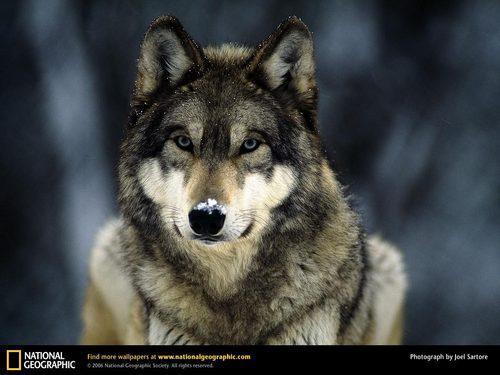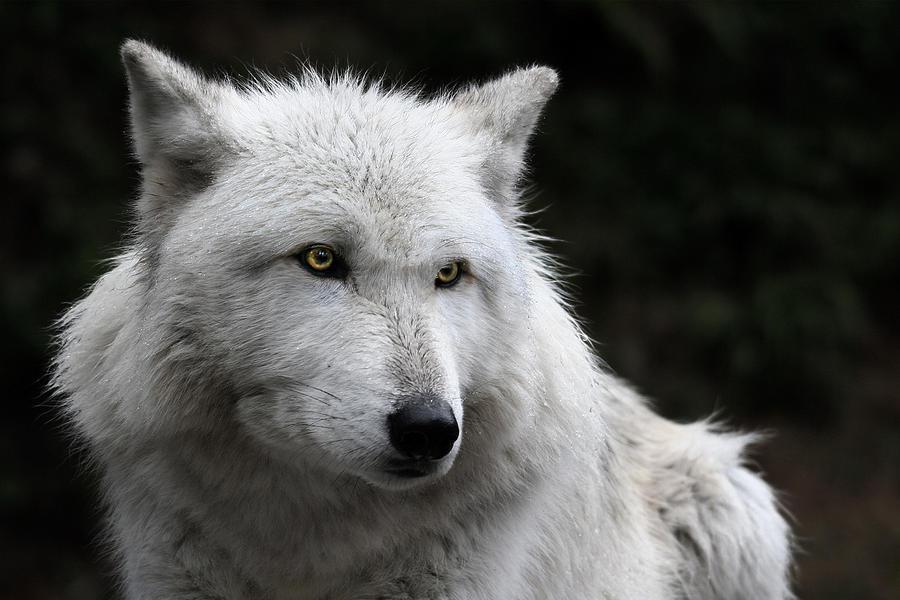The first image is the image on the left, the second image is the image on the right. Considering the images on both sides, is "At least one image shows a wolf baring its fangs." valid? Answer yes or no. No. The first image is the image on the left, the second image is the image on the right. Examine the images to the left and right. Is the description "The dog on the right is baring its teeth." accurate? Answer yes or no. No. 